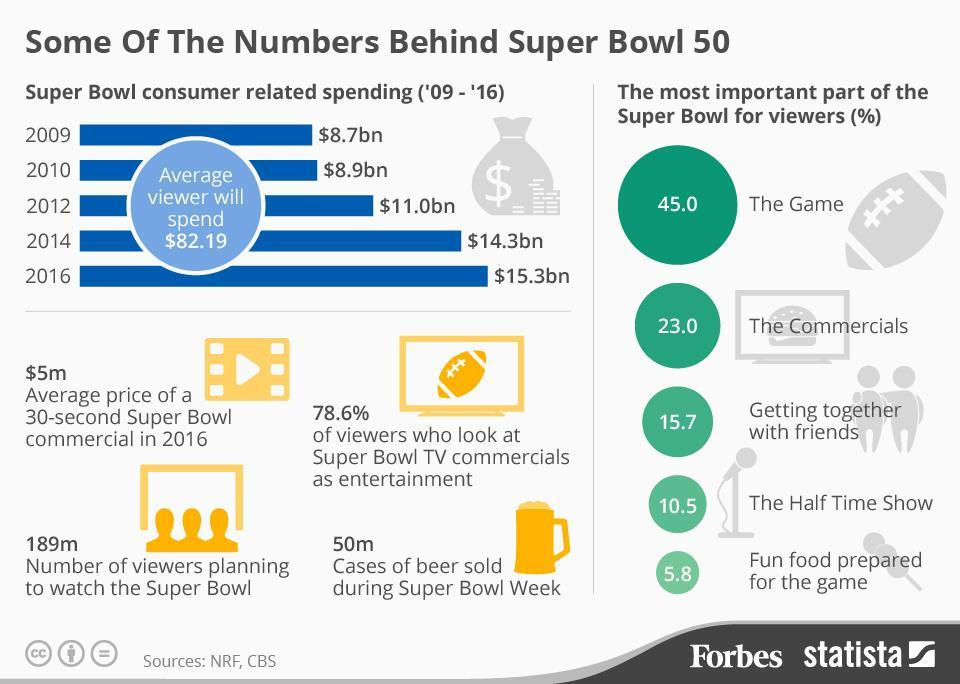What is the number of beer cases sold during the week of Super Bowl?
Answer the question with a short phrase. 50m What is the number of viewers planning to watch the Super Bowl 50? 189m How much did consumers spend on the Super Bowl in 2014? $14.3bn What is the average price of a 30-second Super Bowl commercial in 2016? $5m What percentage of Super Bowl viewers think that the Commercials as the most important part of the game? 23.0 